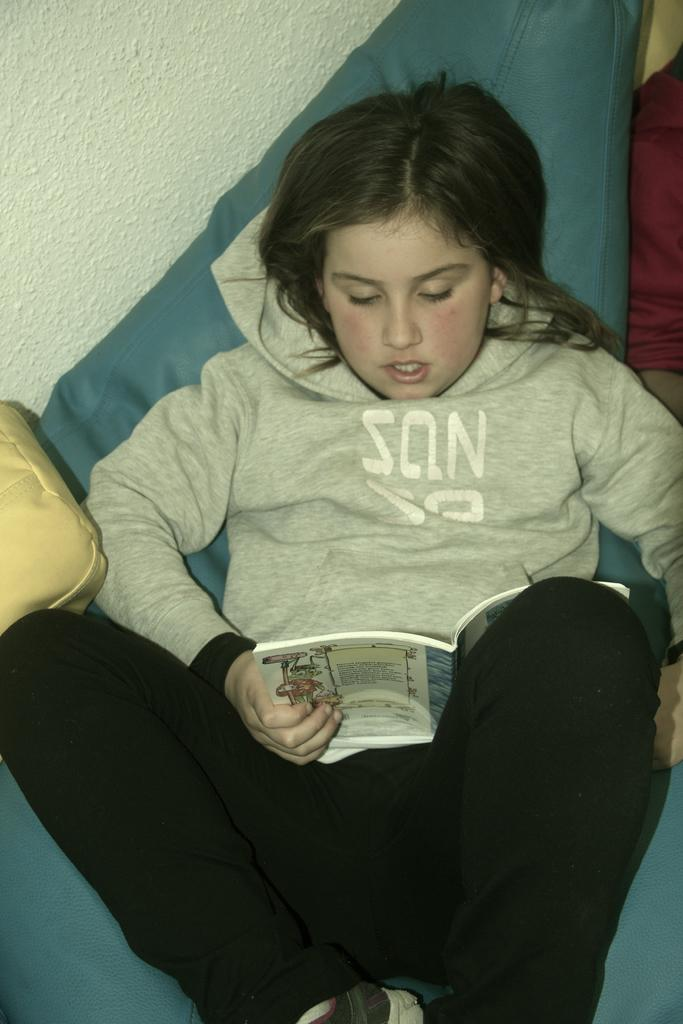Who is the main subject in the image? There is a girl in the image. What is the girl doing in the image? The girl is laying on a sofa set. What can be seen in the background of the image? There is a wall visible in the top left of the image. What type of thrill-seeking apparatus is the girl using in the image? There is no thrill-seeking apparatus present in the image; the girl is simply laying on a sofa set. 